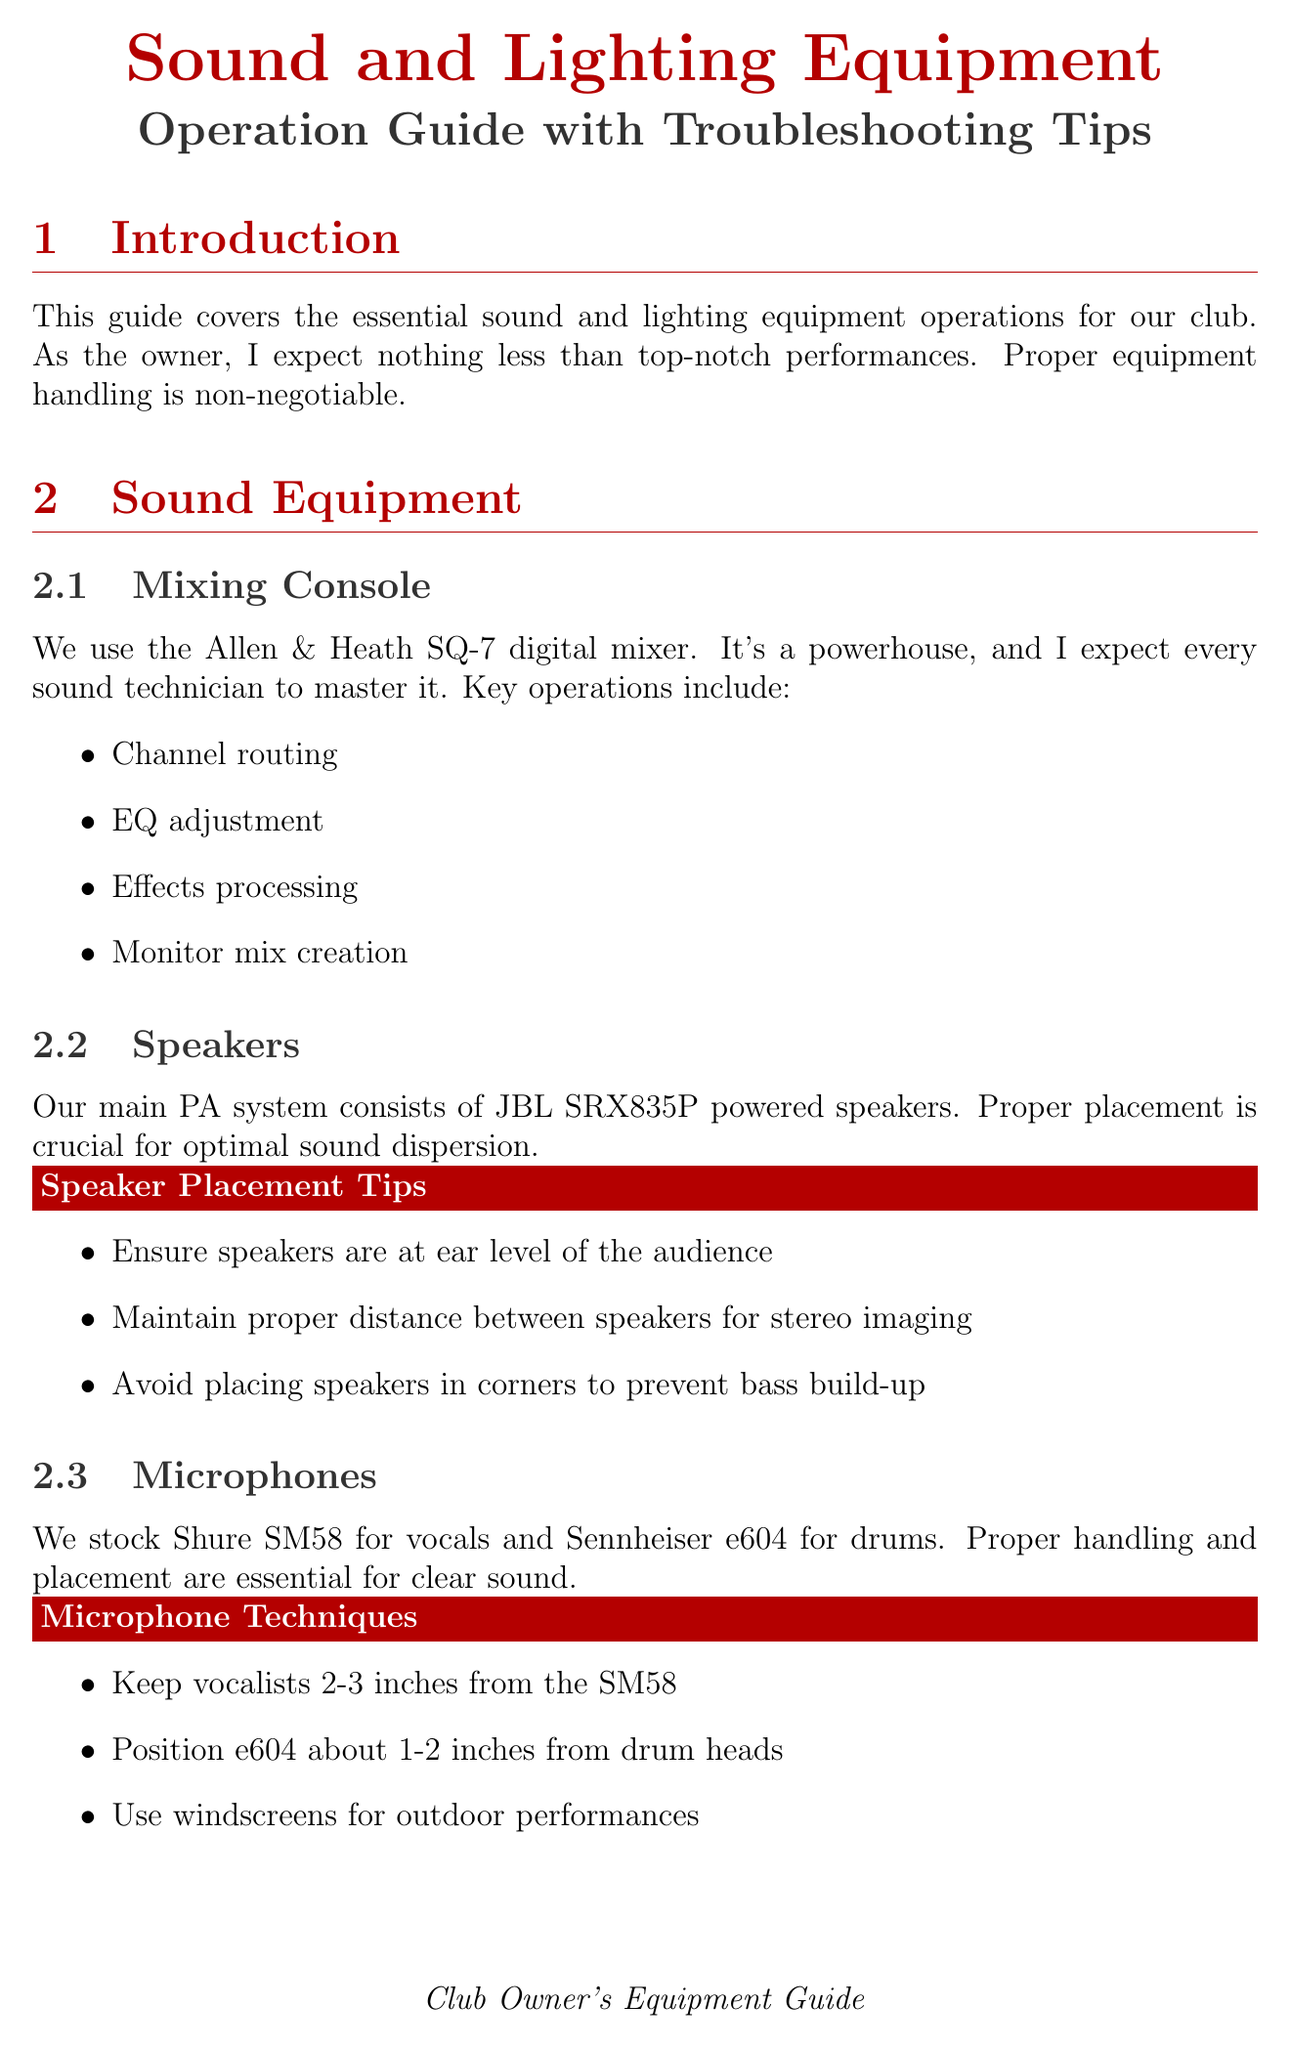What is the model of the mixing console? The mixing console used is the Allen & Heath SQ-7.
Answer: Allen & Heath SQ-7 How often should speaker grills and cabinets be cleaned? The maintenance schedule specifies that speaker grills and cabinets should be cleaned weekly.
Answer: Weekly What type of microphones are stocked for vocals? The manual mentions Shure SM58 as the microphone used for vocals.
Answer: Shure SM58 What is the first solution for no sound from speakers? The first solution listed for no sound from speakers is to check all cable connections.
Answer: Check all cable connections What is a key function of the lighting console? Programming cues is one of the key functions of the lighting console.
Answer: Programming cues How frequently should moving head fixtures be deep cleaned? The maintenance schedule states that moving head fixtures should be deep cleaned bi-monthly.
Answer: Bi-monthly What should be done in case of microphone feedback? One of the solutions is to reduce gain on problematic channels.
Answer: Reduce gain on problematic channels Why is regular maintenance necessary? Regular maintenance is necessary to keep equipment in top shape and prevent failures.
Answer: To keep equipment in top shape What are to be kept clear at all times according to safety protocols? Fire exits must be kept clear at all times as per safety protocols.
Answer: Fire exits 